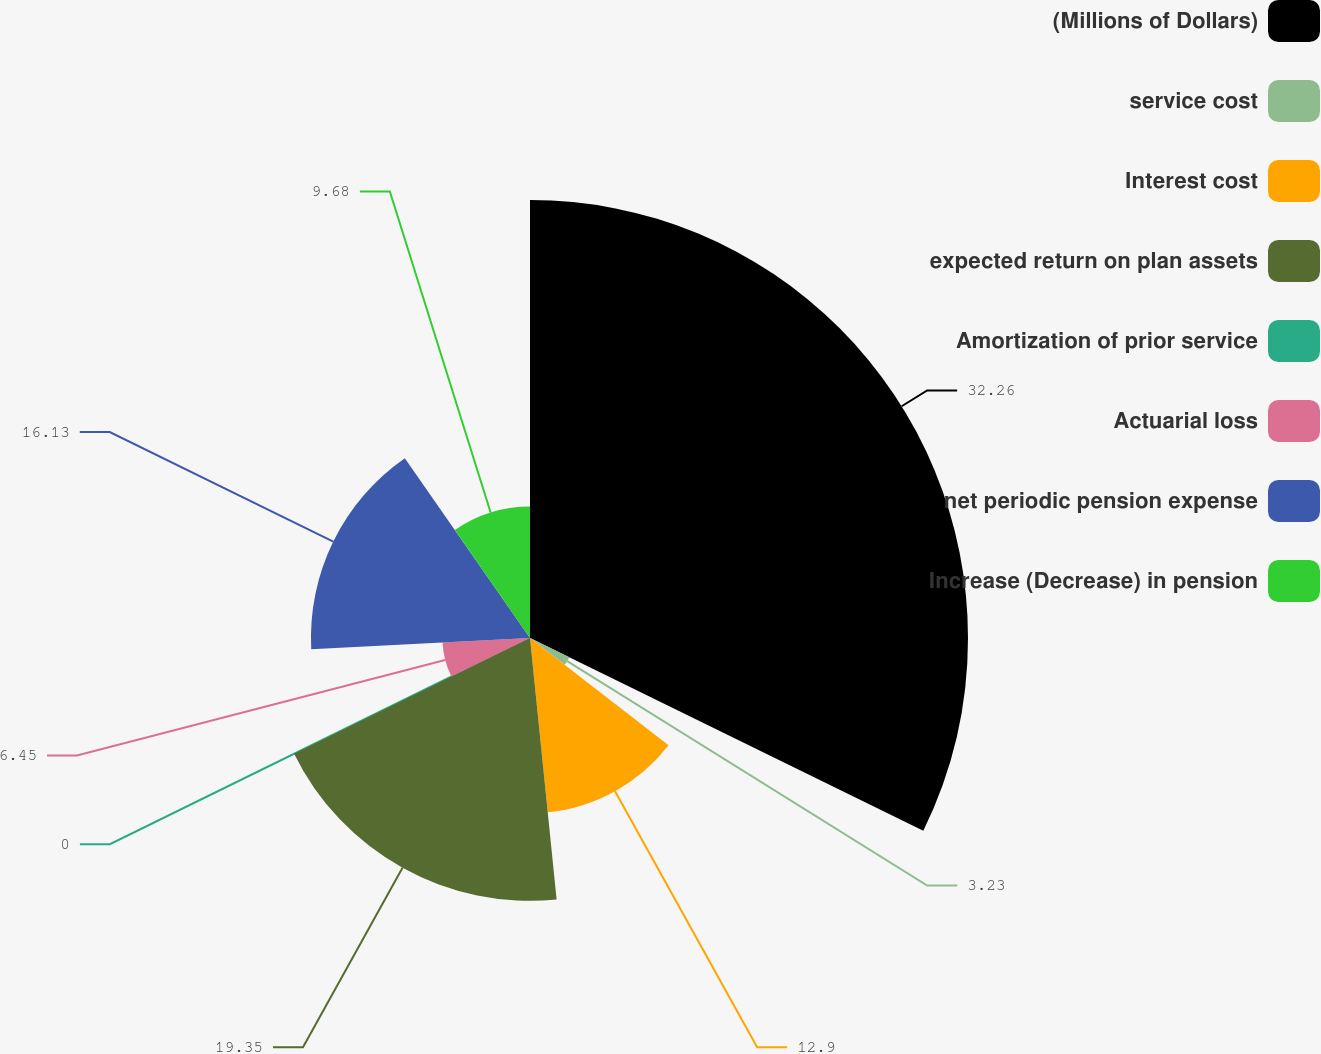<chart> <loc_0><loc_0><loc_500><loc_500><pie_chart><fcel>(Millions of Dollars)<fcel>service cost<fcel>Interest cost<fcel>expected return on plan assets<fcel>Amortization of prior service<fcel>Actuarial loss<fcel>net periodic pension expense<fcel>Increase (Decrease) in pension<nl><fcel>32.25%<fcel>3.23%<fcel>12.9%<fcel>19.35%<fcel>0.0%<fcel>6.45%<fcel>16.13%<fcel>9.68%<nl></chart> 